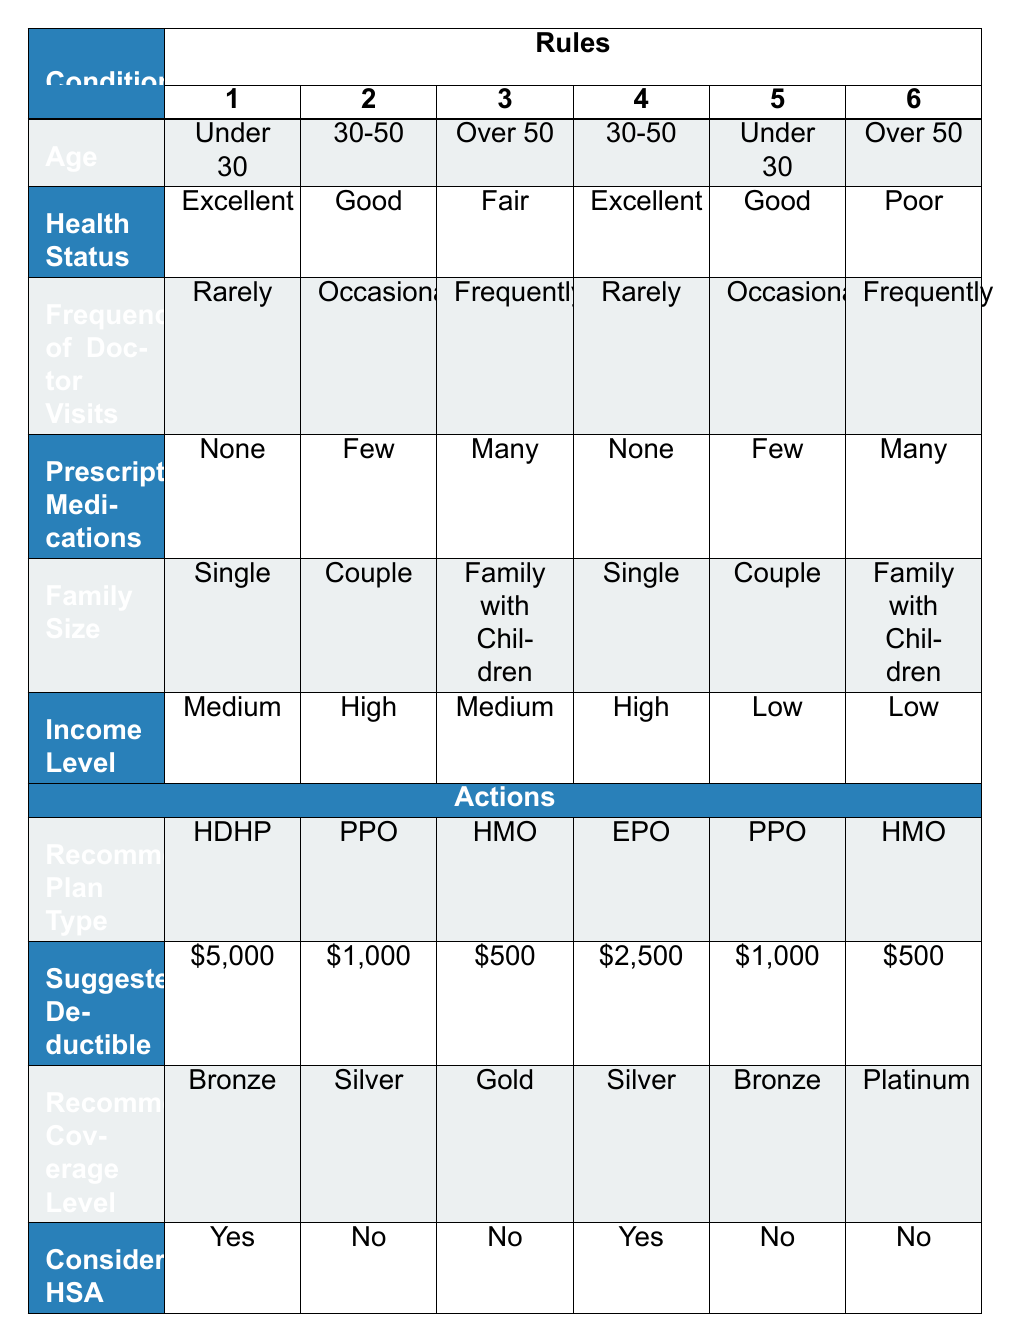What is the recommended plan type for someone who is under 30, has excellent health, rarely visits the doctor, and has no prescription medications? Looking at the table, the first rule matches these conditions exactly, which recommends a High Deductible Health Plan (HDHP).
Answer: HDHP How much is the suggested deductible for a 30-50-year-old in good health who visits the doctor occasionally and has few prescription medications? Referring to the second rule, the suggested deductible for someone aged 30-50 with good health, occasional doctor visits, and few medications is $1,000.
Answer: $1,000 Is there a recommended plan type for individuals over 50 with a poor health status who visit the doctor frequently and have many prescription medications? The sixth rule specifically addresses this scenario, indicating that the recommended plan type is a Health Maintenance Organization (HMO). Therefore, the answer is yes, there is a recommended plan type.
Answer: Yes What is the average suggested deductible for all individuals who are part of a couple? We can analyze the rules for couples: the second rule suggests $1,000 and the fifth rule also suggests $1,000. Therefore, we have two data points: (1,000 + 1,000) = 2,000. Dividing this by the number of couples (2) gives us an average of $1,000.
Answer: $1,000 For a family with children, what plan type is recommended if they are over 50, fair in health, visit the doctor frequently, and have many prescription medications? The third rule outlines these conditions and suggests a Health Maintenance Organization (HMO) as the recommended plan type for this case.
Answer: HMO What is the suggested deductible for a single individual under 30 with good health who occasionally visits the doctor and has few prescription medications? Looking at the fifth rule, which matches these criteria, the suggested deductible for these conditions is $1,000.
Answer: $1,000 Are there any recommended plan types that consider Health Savings Accounts (HSA) for individuals over 50? Reviewing the rules, only the first and fourth rules suggest plans that consider a Health Savings Account (HSA). Therefore, yes, there are recommended plan types that do consider HSA for individuals over 50.
Answer: Yes What is the recommended coverage level for an individual aged 30-50 with excellent health who is single and visits the doctor rarely? The fourth rule indicates that for these conditions, the recommended coverage level is Silver.
Answer: Silver 